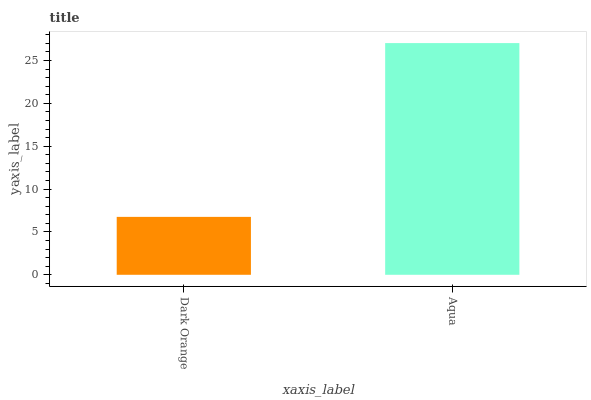Is Dark Orange the minimum?
Answer yes or no. Yes. Is Aqua the maximum?
Answer yes or no. Yes. Is Aqua the minimum?
Answer yes or no. No. Is Aqua greater than Dark Orange?
Answer yes or no. Yes. Is Dark Orange less than Aqua?
Answer yes or no. Yes. Is Dark Orange greater than Aqua?
Answer yes or no. No. Is Aqua less than Dark Orange?
Answer yes or no. No. Is Aqua the high median?
Answer yes or no. Yes. Is Dark Orange the low median?
Answer yes or no. Yes. Is Dark Orange the high median?
Answer yes or no. No. Is Aqua the low median?
Answer yes or no. No. 